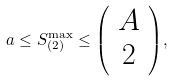Convert formula to latex. <formula><loc_0><loc_0><loc_500><loc_500>a \leq S _ { ( 2 ) } ^ { \max } \leq { \left ( \begin{array} { c } A \\ 2 \end{array} \right ) } ,</formula> 